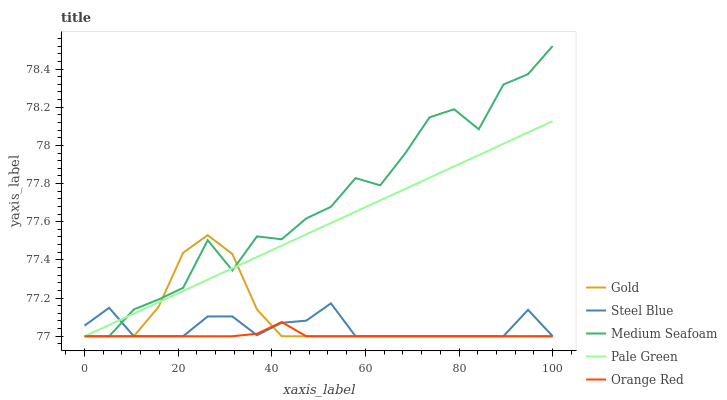Does Orange Red have the minimum area under the curve?
Answer yes or no. Yes. Does Medium Seafoam have the maximum area under the curve?
Answer yes or no. Yes. Does Pale Green have the minimum area under the curve?
Answer yes or no. No. Does Pale Green have the maximum area under the curve?
Answer yes or no. No. Is Pale Green the smoothest?
Answer yes or no. Yes. Is Medium Seafoam the roughest?
Answer yes or no. Yes. Is Steel Blue the smoothest?
Answer yes or no. No. Is Steel Blue the roughest?
Answer yes or no. No. Does Orange Red have the lowest value?
Answer yes or no. Yes. Does Medium Seafoam have the highest value?
Answer yes or no. Yes. Does Pale Green have the highest value?
Answer yes or no. No. Does Medium Seafoam intersect Pale Green?
Answer yes or no. Yes. Is Medium Seafoam less than Pale Green?
Answer yes or no. No. Is Medium Seafoam greater than Pale Green?
Answer yes or no. No. 